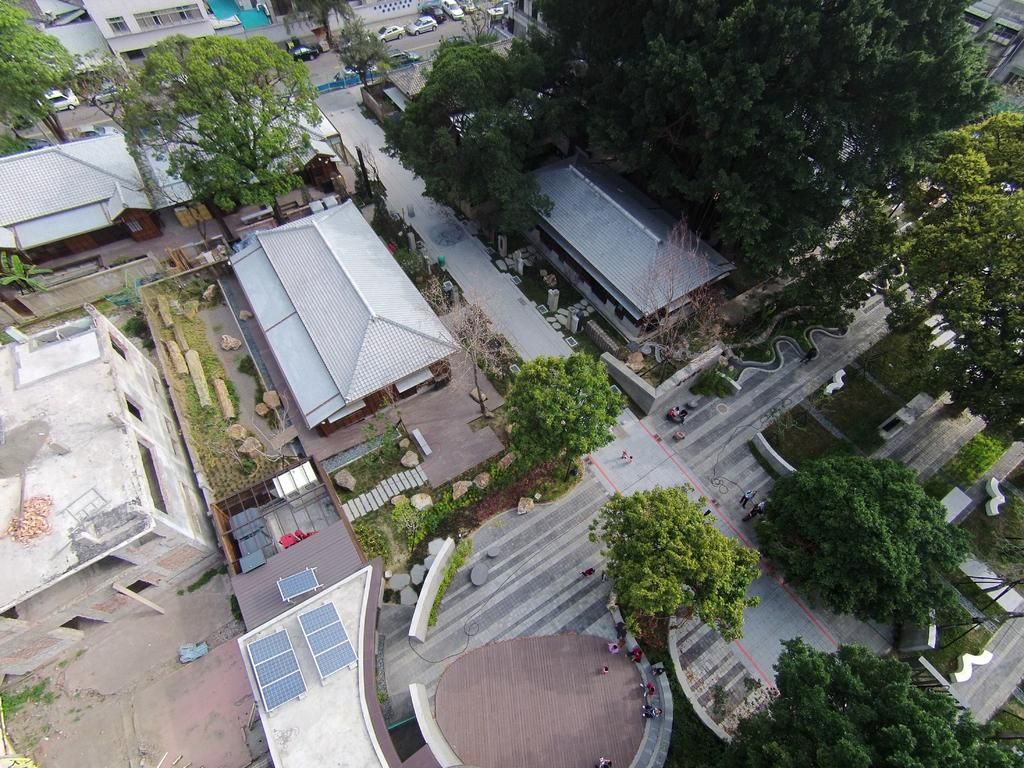What type of view is shown in the image? The image is a top view of a city. What structures can be seen in the image? There are buildings in the image. What natural elements are present in the image? There are trees in the image. What type of transportation can be seen in the image? There are vehicles on the road in the image. What type of wool is being used to make the window in the image? There is no wool or window present in the image; it is a top view of a city with buildings, trees, and vehicles. 